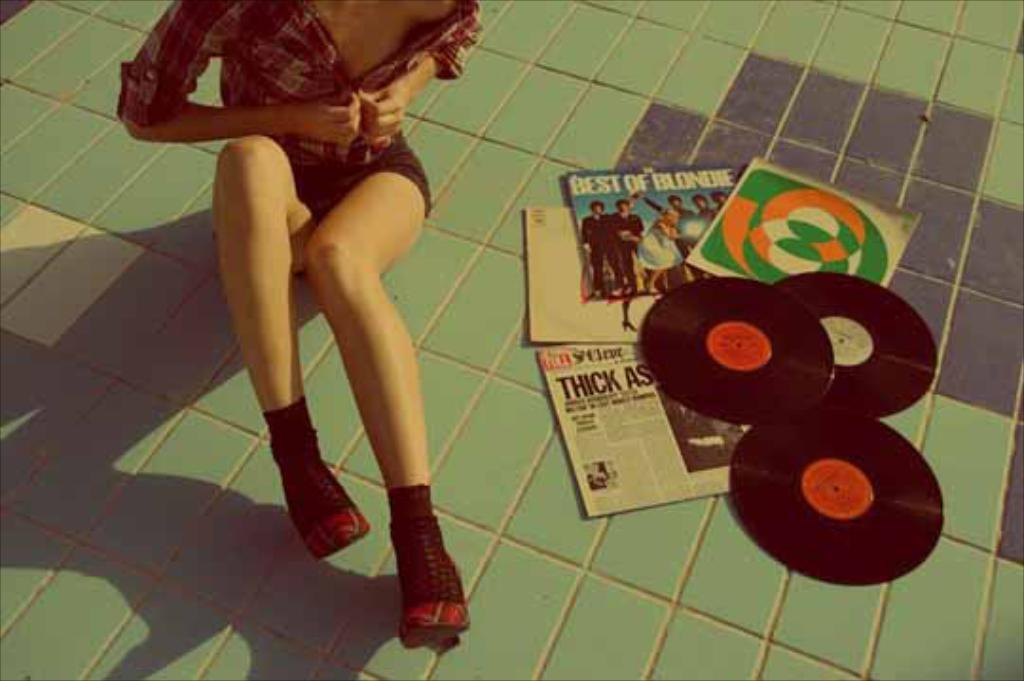Who is the main subject in the image? There is a woman in the center of the image. What is the woman doing in the image? The woman is sitting. What items can be seen near the woman? There are books and DVDs in the image. What is the setting of the image? There is a walkway at the bottom of the image. Can you see a dog swimming in the image? There is no dog or swimming activity present in the image. 